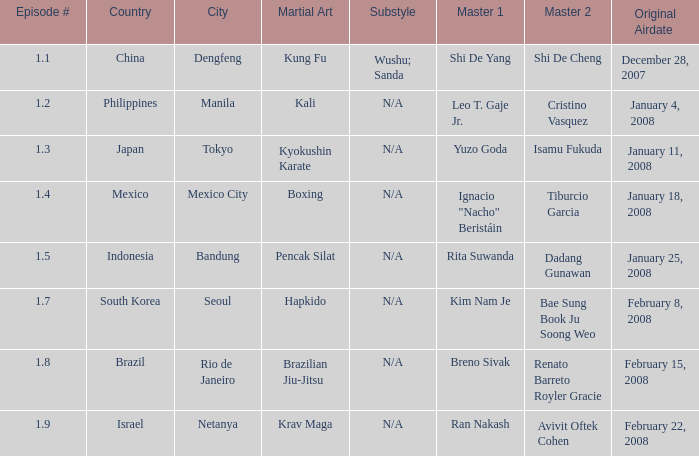How many masters fought using a boxing style? 1.0. 